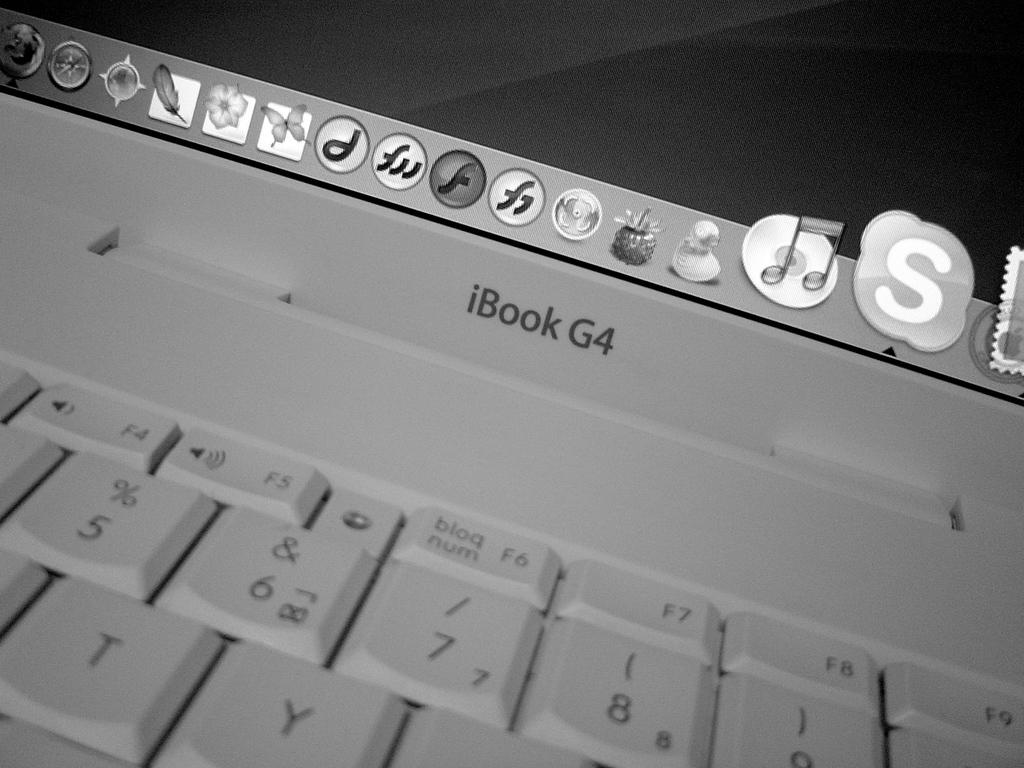<image>
Present a compact description of the photo's key features. An iBook G4 sits open with many apps displayed. 